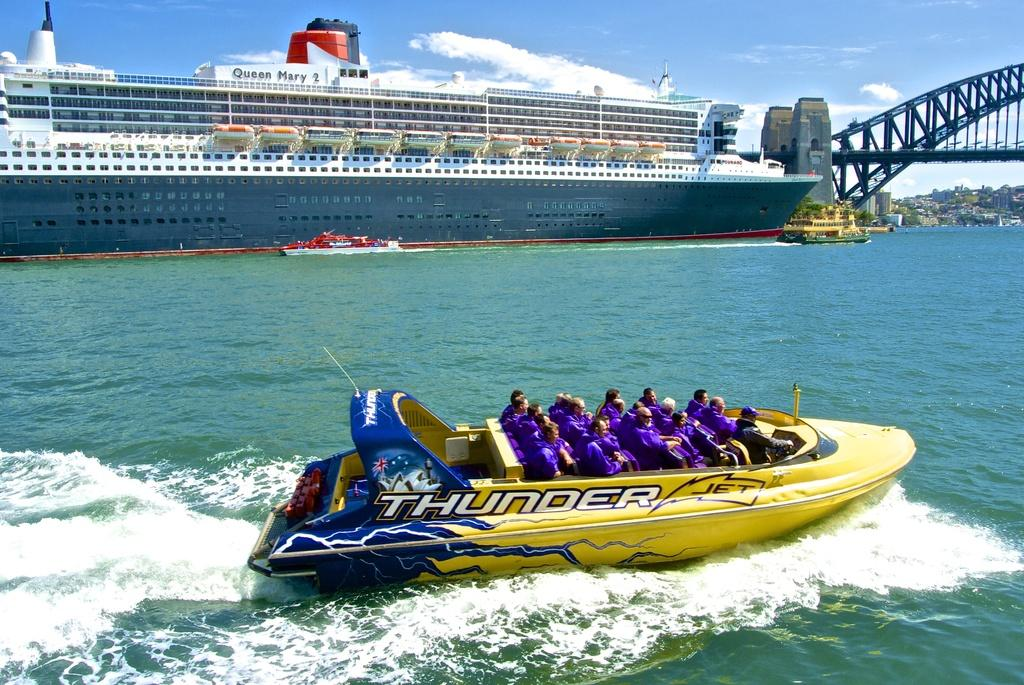<image>
Create a compact narrative representing the image presented. Group of people riding a Thunder boat in the waters. 